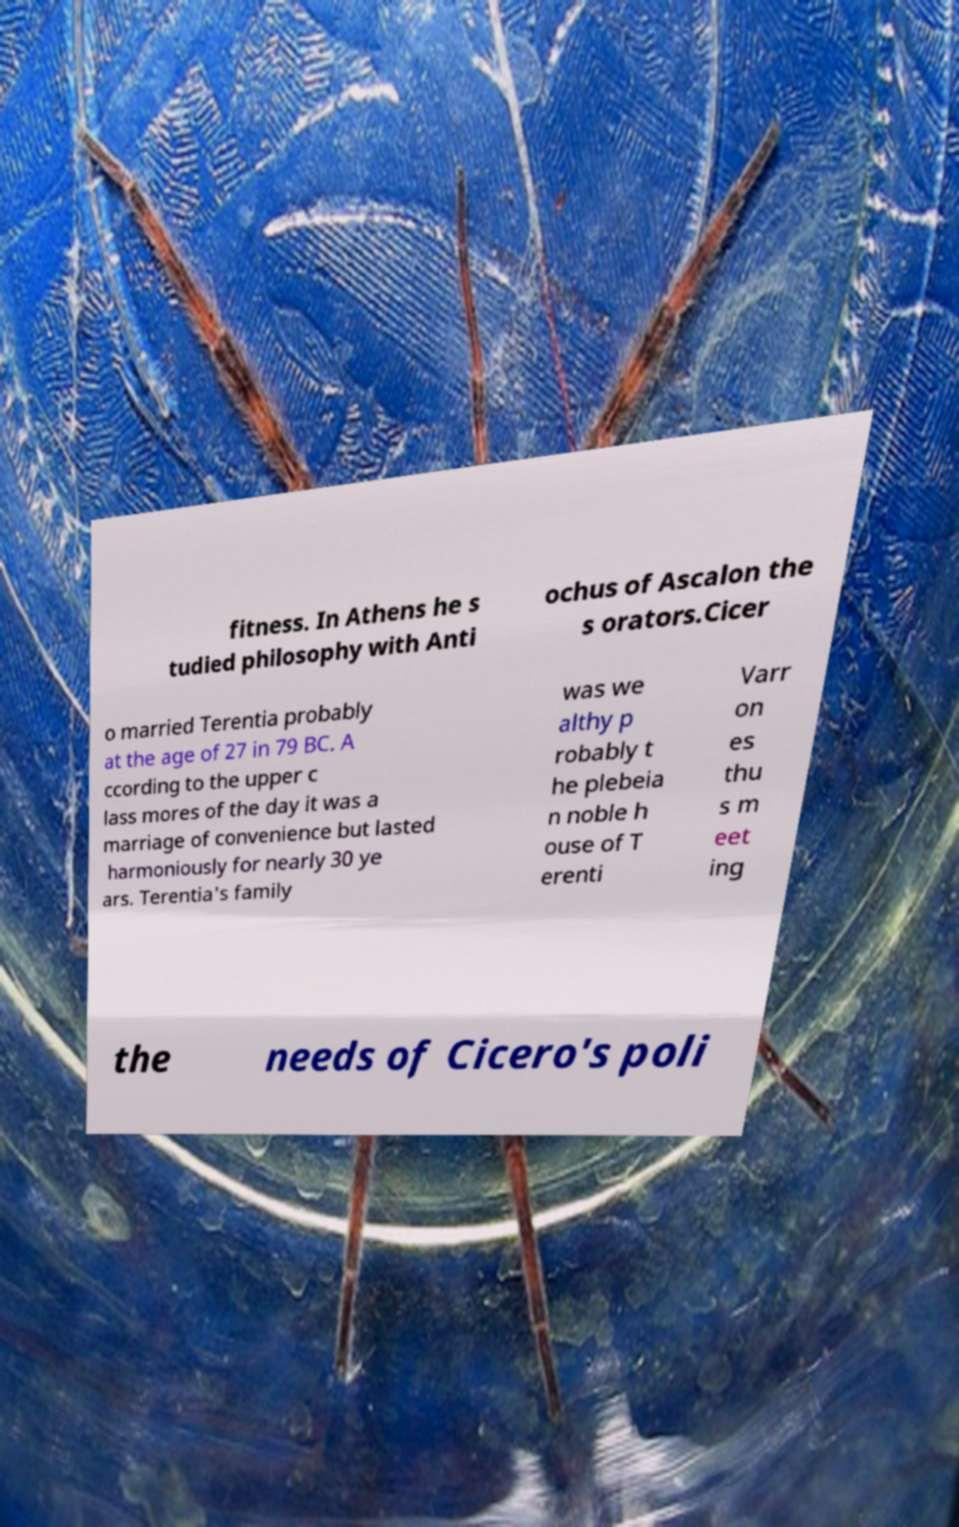What messages or text are displayed in this image? I need them in a readable, typed format. fitness. In Athens he s tudied philosophy with Anti ochus of Ascalon the s orators.Cicer o married Terentia probably at the age of 27 in 79 BC. A ccording to the upper c lass mores of the day it was a marriage of convenience but lasted harmoniously for nearly 30 ye ars. Terentia's family was we althy p robably t he plebeia n noble h ouse of T erenti Varr on es thu s m eet ing the needs of Cicero's poli 